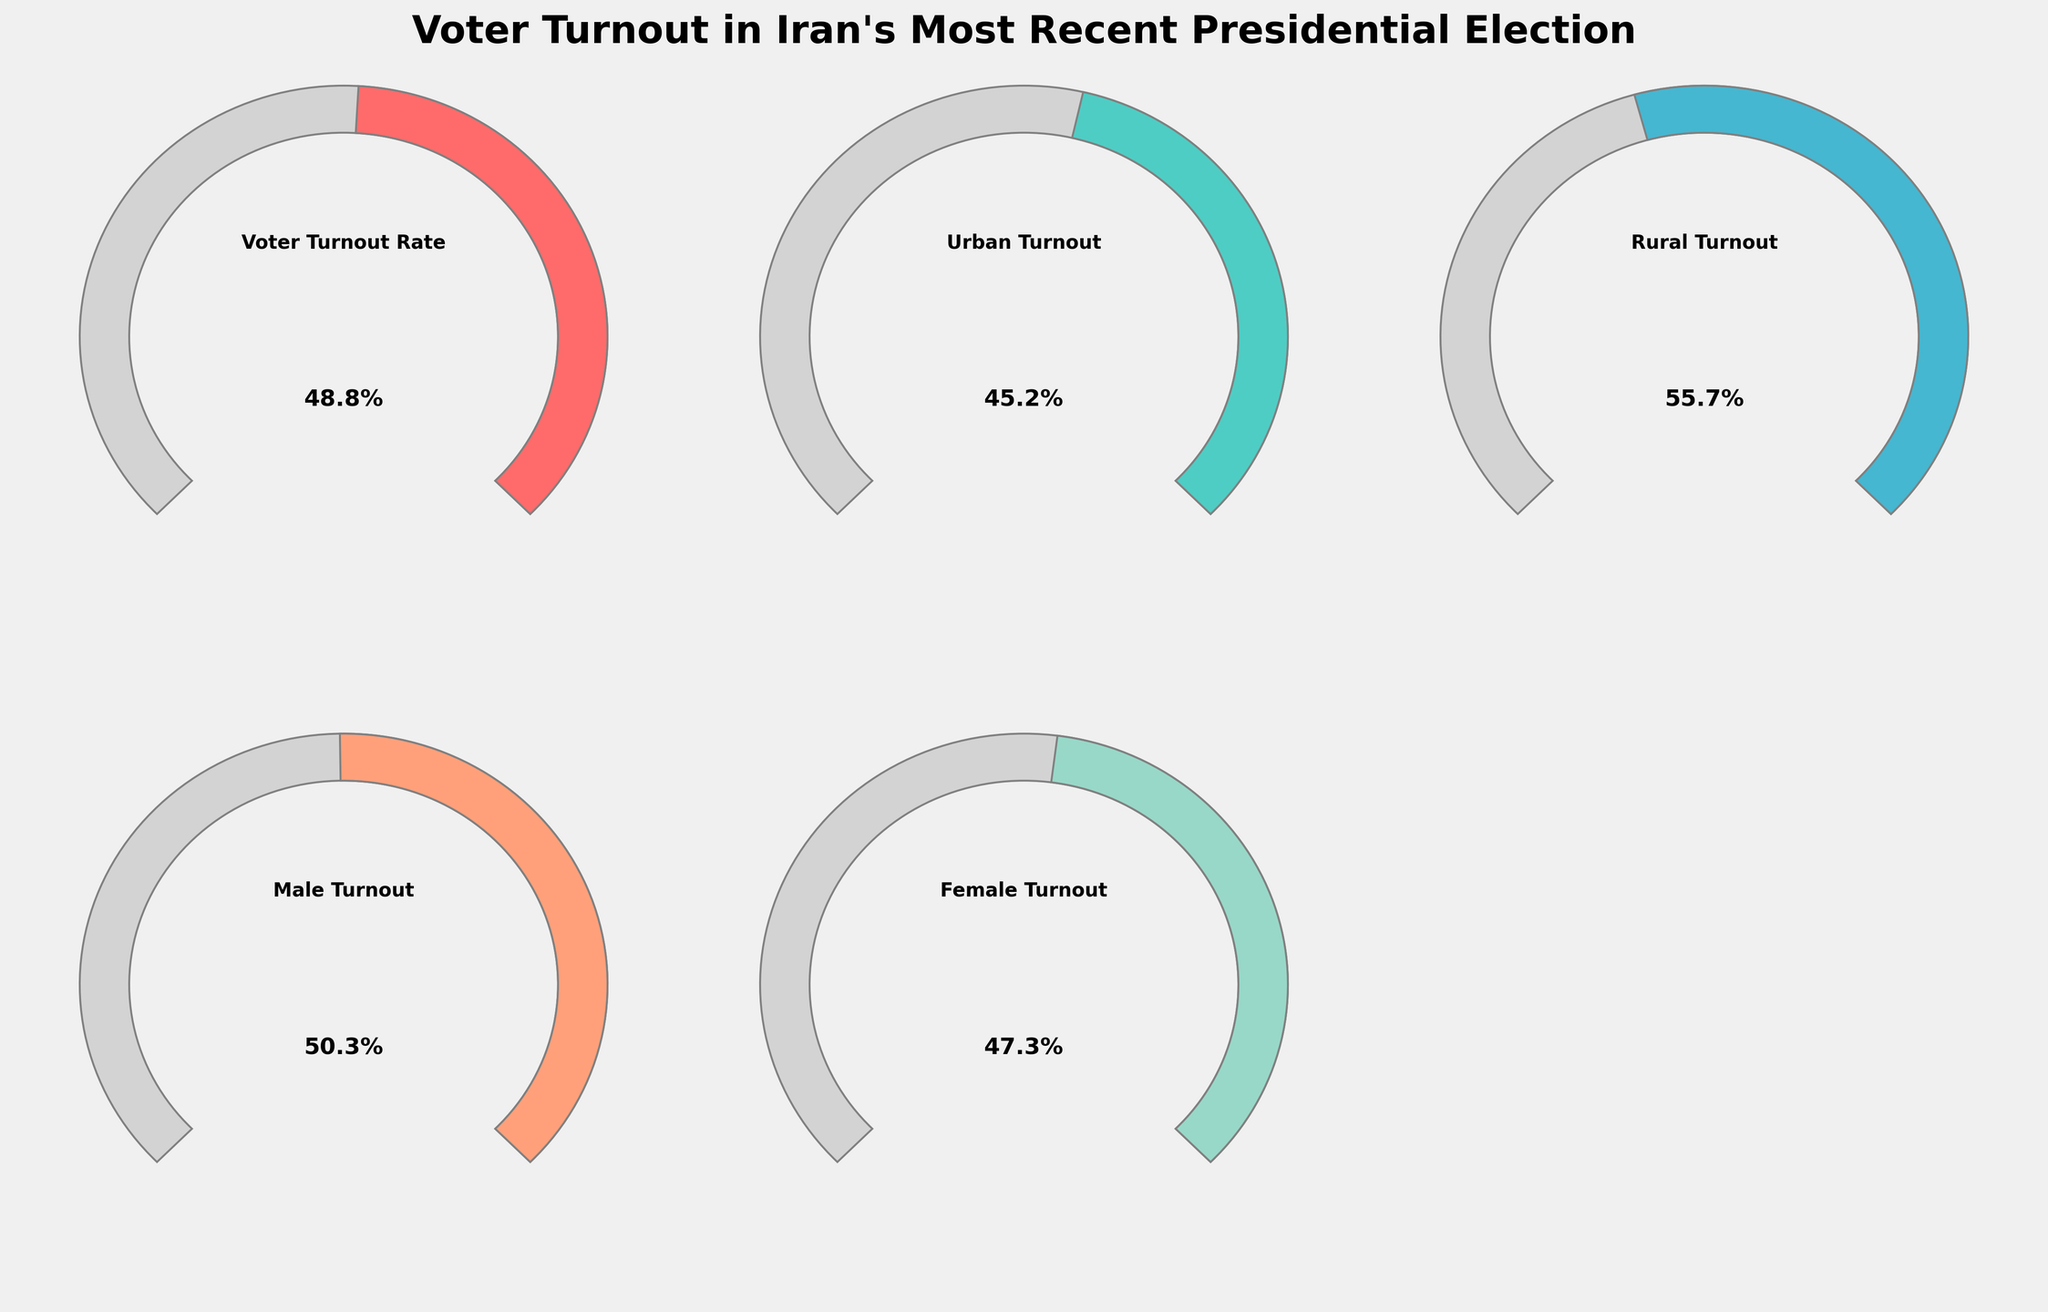What's the overall voter turnout rate in Iran's most recent presidential election? According to the gauge chart, the "Voter Turnout Rate" section shows 48.8%.
Answer: 48.8% Which category has the highest voter turnout rate? By visually comparing the angles of the gauges, the "Rural Turnout" section has the largest filled portion, indicating the highest percentage at 55.7%.
Answer: Rural Turnout How does the female turnout rate compare to the male turnout rate? The female turnout rate is 47.3%, and the male turnout rate is 50.3%. Observe the gauges to see that the female turnout is slightly lower than the male turnout.
Answer: Female turnout is lower than male turnout What can you deduce about urban versus rural voter turnout rates? The gauges show that the urban turnout is 45.2%, while the rural turnout is 55.7%. This indicates that rural voters turned out more than urban voters.
Answer: Rural turnout is higher than urban turnout What's the difference between the highest and lowest voter turnout rates? The highest voter turnout rate is 55.7% (Rural Turnout), and the lowest is 45.2% (Urban Turnout). The difference is 55.7% - 45.2% = 10.5%.
Answer: 10.5% Which category is closest to half of the turnout rate? Examining the gauges, the "Male Turnout" at 50.3% is closest to the 50% mark, indicating roughly half of the turnout rate.
Answer: Male Turnout What's the average voter turnout rate across all categories? To calculate the average, sum all the rates: (48.8 + 45.2 + 55.7 + 50.3 + 47.3) = 247.3, then divide by the number of categories, 247.3 / 5 = 49.46%.
Answer: 49.46% How much greater is the rural turnout compared to the urban turnout? The rural turnout is 55.7%, and the urban turnout is 45.2%. The difference is 55.7% - 45.2% = 10.5%.
Answer: 10.5% In terms of voter turnout, which category is the closest to the overall voter turnout rate of 48.8%? Comparing all gauges, "Female Turnout" at 47.3% is closest in value to 48.8%.
Answer: Female Turnout 